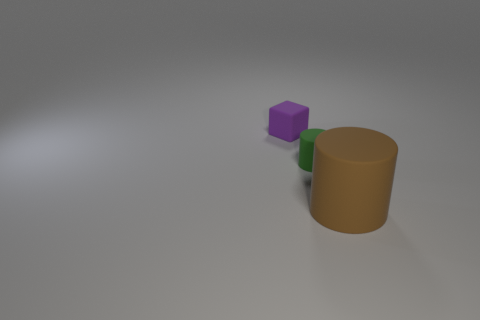What number of cylinders are there?
Offer a terse response. 2. The large object that is the same material as the purple cube is what shape?
Provide a short and direct response. Cylinder. Are there fewer small green cylinders that are to the left of the green object than tiny blue blocks?
Offer a very short reply. No. What material is the small thing that is on the left side of the small green cylinder?
Give a very brief answer. Rubber. What number of other things are there of the same size as the purple object?
Offer a terse response. 1. Is the size of the purple object the same as the matte cylinder that is in front of the green thing?
Make the answer very short. No. There is a small rubber thing on the right side of the thing that is to the left of the cylinder behind the big rubber cylinder; what is its shape?
Offer a very short reply. Cylinder. Are there fewer small gray blocks than purple objects?
Make the answer very short. Yes. Are there any big rubber cylinders to the right of the green thing?
Give a very brief answer. Yes. What shape is the object that is both behind the brown matte cylinder and in front of the tiny purple matte block?
Make the answer very short. Cylinder. 